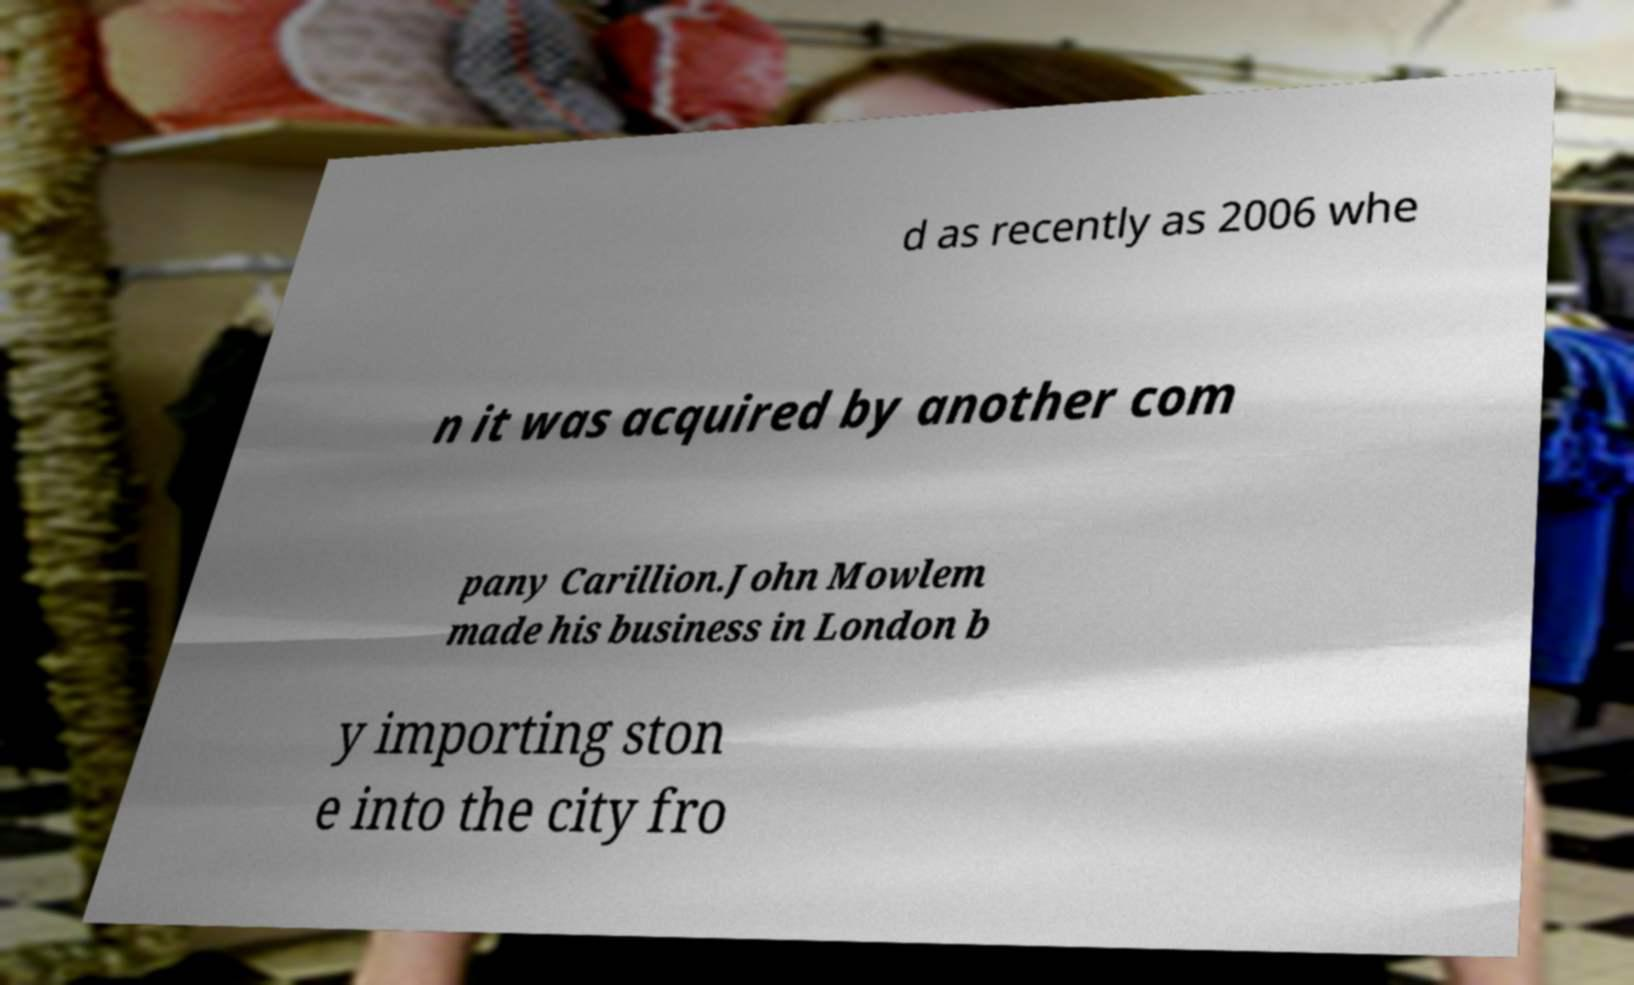Please read and relay the text visible in this image. What does it say? d as recently as 2006 whe n it was acquired by another com pany Carillion.John Mowlem made his business in London b y importing ston e into the city fro 